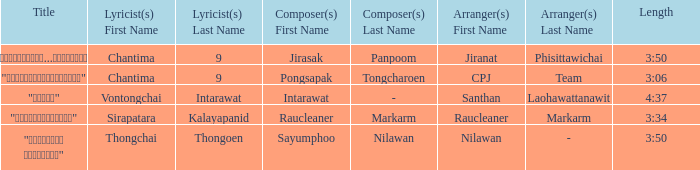Who was the composer of "ขอโทษ"? Intarawat. 